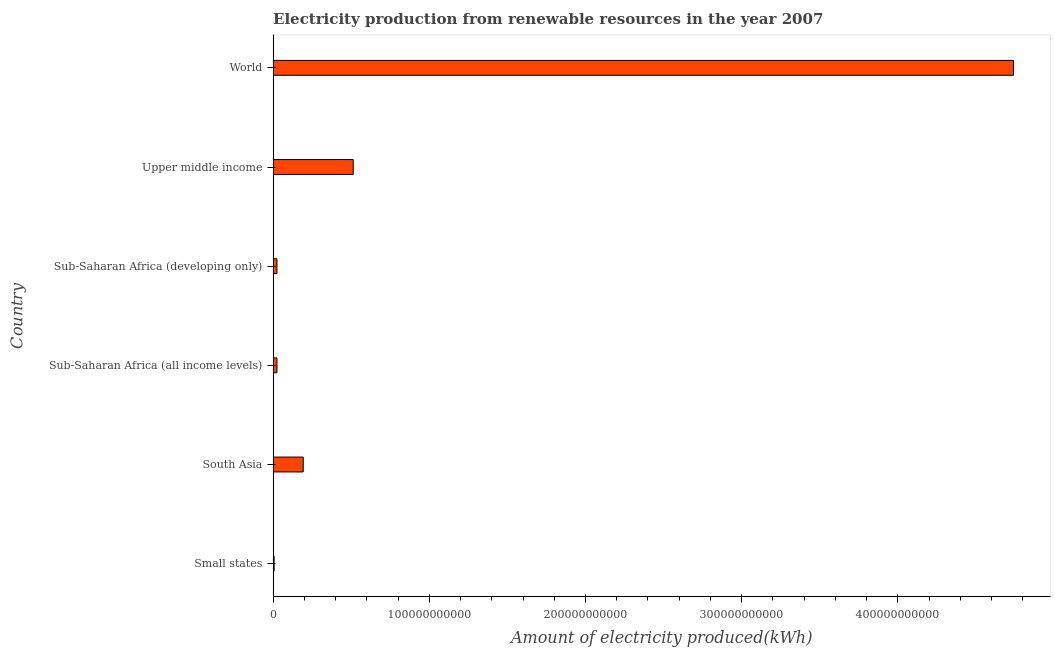Does the graph contain grids?
Ensure brevity in your answer.  No. What is the title of the graph?
Your answer should be compact. Electricity production from renewable resources in the year 2007. What is the label or title of the X-axis?
Ensure brevity in your answer.  Amount of electricity produced(kWh). What is the amount of electricity produced in World?
Provide a short and direct response. 4.74e+11. Across all countries, what is the maximum amount of electricity produced?
Provide a succinct answer. 4.74e+11. Across all countries, what is the minimum amount of electricity produced?
Offer a very short reply. 6.33e+08. In which country was the amount of electricity produced minimum?
Your response must be concise. Small states. What is the sum of the amount of electricity produced?
Ensure brevity in your answer.  5.50e+11. What is the difference between the amount of electricity produced in South Asia and World?
Offer a terse response. -4.55e+11. What is the average amount of electricity produced per country?
Make the answer very short. 9.17e+1. What is the median amount of electricity produced?
Your answer should be very brief. 1.09e+1. In how many countries, is the amount of electricity produced greater than 140000000000 kWh?
Your response must be concise. 1. What is the ratio of the amount of electricity produced in Sub-Saharan Africa (all income levels) to that in World?
Give a very brief answer. 0.01. Is the amount of electricity produced in Small states less than that in Upper middle income?
Your response must be concise. Yes. Is the difference between the amount of electricity produced in South Asia and Sub-Saharan Africa (all income levels) greater than the difference between any two countries?
Your response must be concise. No. What is the difference between the highest and the second highest amount of electricity produced?
Give a very brief answer. 4.23e+11. What is the difference between the highest and the lowest amount of electricity produced?
Make the answer very short. 4.73e+11. In how many countries, is the amount of electricity produced greater than the average amount of electricity produced taken over all countries?
Your response must be concise. 1. How many bars are there?
Offer a terse response. 6. How many countries are there in the graph?
Keep it short and to the point. 6. What is the difference between two consecutive major ticks on the X-axis?
Provide a short and direct response. 1.00e+11. Are the values on the major ticks of X-axis written in scientific E-notation?
Make the answer very short. No. What is the Amount of electricity produced(kWh) in Small states?
Your answer should be compact. 6.33e+08. What is the Amount of electricity produced(kWh) in South Asia?
Provide a succinct answer. 1.93e+1. What is the Amount of electricity produced(kWh) in Sub-Saharan Africa (all income levels)?
Make the answer very short. 2.45e+09. What is the Amount of electricity produced(kWh) of Sub-Saharan Africa (developing only)?
Your answer should be compact. 2.45e+09. What is the Amount of electricity produced(kWh) in Upper middle income?
Your response must be concise. 5.13e+1. What is the Amount of electricity produced(kWh) of World?
Make the answer very short. 4.74e+11. What is the difference between the Amount of electricity produced(kWh) in Small states and South Asia?
Your response must be concise. -1.86e+1. What is the difference between the Amount of electricity produced(kWh) in Small states and Sub-Saharan Africa (all income levels)?
Provide a succinct answer. -1.82e+09. What is the difference between the Amount of electricity produced(kWh) in Small states and Sub-Saharan Africa (developing only)?
Ensure brevity in your answer.  -1.82e+09. What is the difference between the Amount of electricity produced(kWh) in Small states and Upper middle income?
Give a very brief answer. -5.06e+1. What is the difference between the Amount of electricity produced(kWh) in Small states and World?
Ensure brevity in your answer.  -4.73e+11. What is the difference between the Amount of electricity produced(kWh) in South Asia and Sub-Saharan Africa (all income levels)?
Offer a terse response. 1.68e+1. What is the difference between the Amount of electricity produced(kWh) in South Asia and Sub-Saharan Africa (developing only)?
Give a very brief answer. 1.68e+1. What is the difference between the Amount of electricity produced(kWh) in South Asia and Upper middle income?
Offer a very short reply. -3.20e+1. What is the difference between the Amount of electricity produced(kWh) in South Asia and World?
Your response must be concise. -4.55e+11. What is the difference between the Amount of electricity produced(kWh) in Sub-Saharan Africa (all income levels) and Sub-Saharan Africa (developing only)?
Make the answer very short. 0. What is the difference between the Amount of electricity produced(kWh) in Sub-Saharan Africa (all income levels) and Upper middle income?
Your answer should be compact. -4.88e+1. What is the difference between the Amount of electricity produced(kWh) in Sub-Saharan Africa (all income levels) and World?
Your response must be concise. -4.72e+11. What is the difference between the Amount of electricity produced(kWh) in Sub-Saharan Africa (developing only) and Upper middle income?
Your answer should be very brief. -4.88e+1. What is the difference between the Amount of electricity produced(kWh) in Sub-Saharan Africa (developing only) and World?
Keep it short and to the point. -4.72e+11. What is the difference between the Amount of electricity produced(kWh) in Upper middle income and World?
Ensure brevity in your answer.  -4.23e+11. What is the ratio of the Amount of electricity produced(kWh) in Small states to that in South Asia?
Provide a short and direct response. 0.03. What is the ratio of the Amount of electricity produced(kWh) in Small states to that in Sub-Saharan Africa (all income levels)?
Provide a short and direct response. 0.26. What is the ratio of the Amount of electricity produced(kWh) in Small states to that in Sub-Saharan Africa (developing only)?
Give a very brief answer. 0.26. What is the ratio of the Amount of electricity produced(kWh) in Small states to that in Upper middle income?
Provide a succinct answer. 0.01. What is the ratio of the Amount of electricity produced(kWh) in Small states to that in World?
Offer a very short reply. 0. What is the ratio of the Amount of electricity produced(kWh) in South Asia to that in Sub-Saharan Africa (all income levels)?
Your answer should be compact. 7.86. What is the ratio of the Amount of electricity produced(kWh) in South Asia to that in Sub-Saharan Africa (developing only)?
Provide a succinct answer. 7.86. What is the ratio of the Amount of electricity produced(kWh) in South Asia to that in Upper middle income?
Your response must be concise. 0.38. What is the ratio of the Amount of electricity produced(kWh) in South Asia to that in World?
Make the answer very short. 0.04. What is the ratio of the Amount of electricity produced(kWh) in Sub-Saharan Africa (all income levels) to that in Upper middle income?
Your answer should be compact. 0.05. What is the ratio of the Amount of electricity produced(kWh) in Sub-Saharan Africa (all income levels) to that in World?
Make the answer very short. 0.01. What is the ratio of the Amount of electricity produced(kWh) in Sub-Saharan Africa (developing only) to that in Upper middle income?
Your response must be concise. 0.05. What is the ratio of the Amount of electricity produced(kWh) in Sub-Saharan Africa (developing only) to that in World?
Give a very brief answer. 0.01. What is the ratio of the Amount of electricity produced(kWh) in Upper middle income to that in World?
Offer a very short reply. 0.11. 